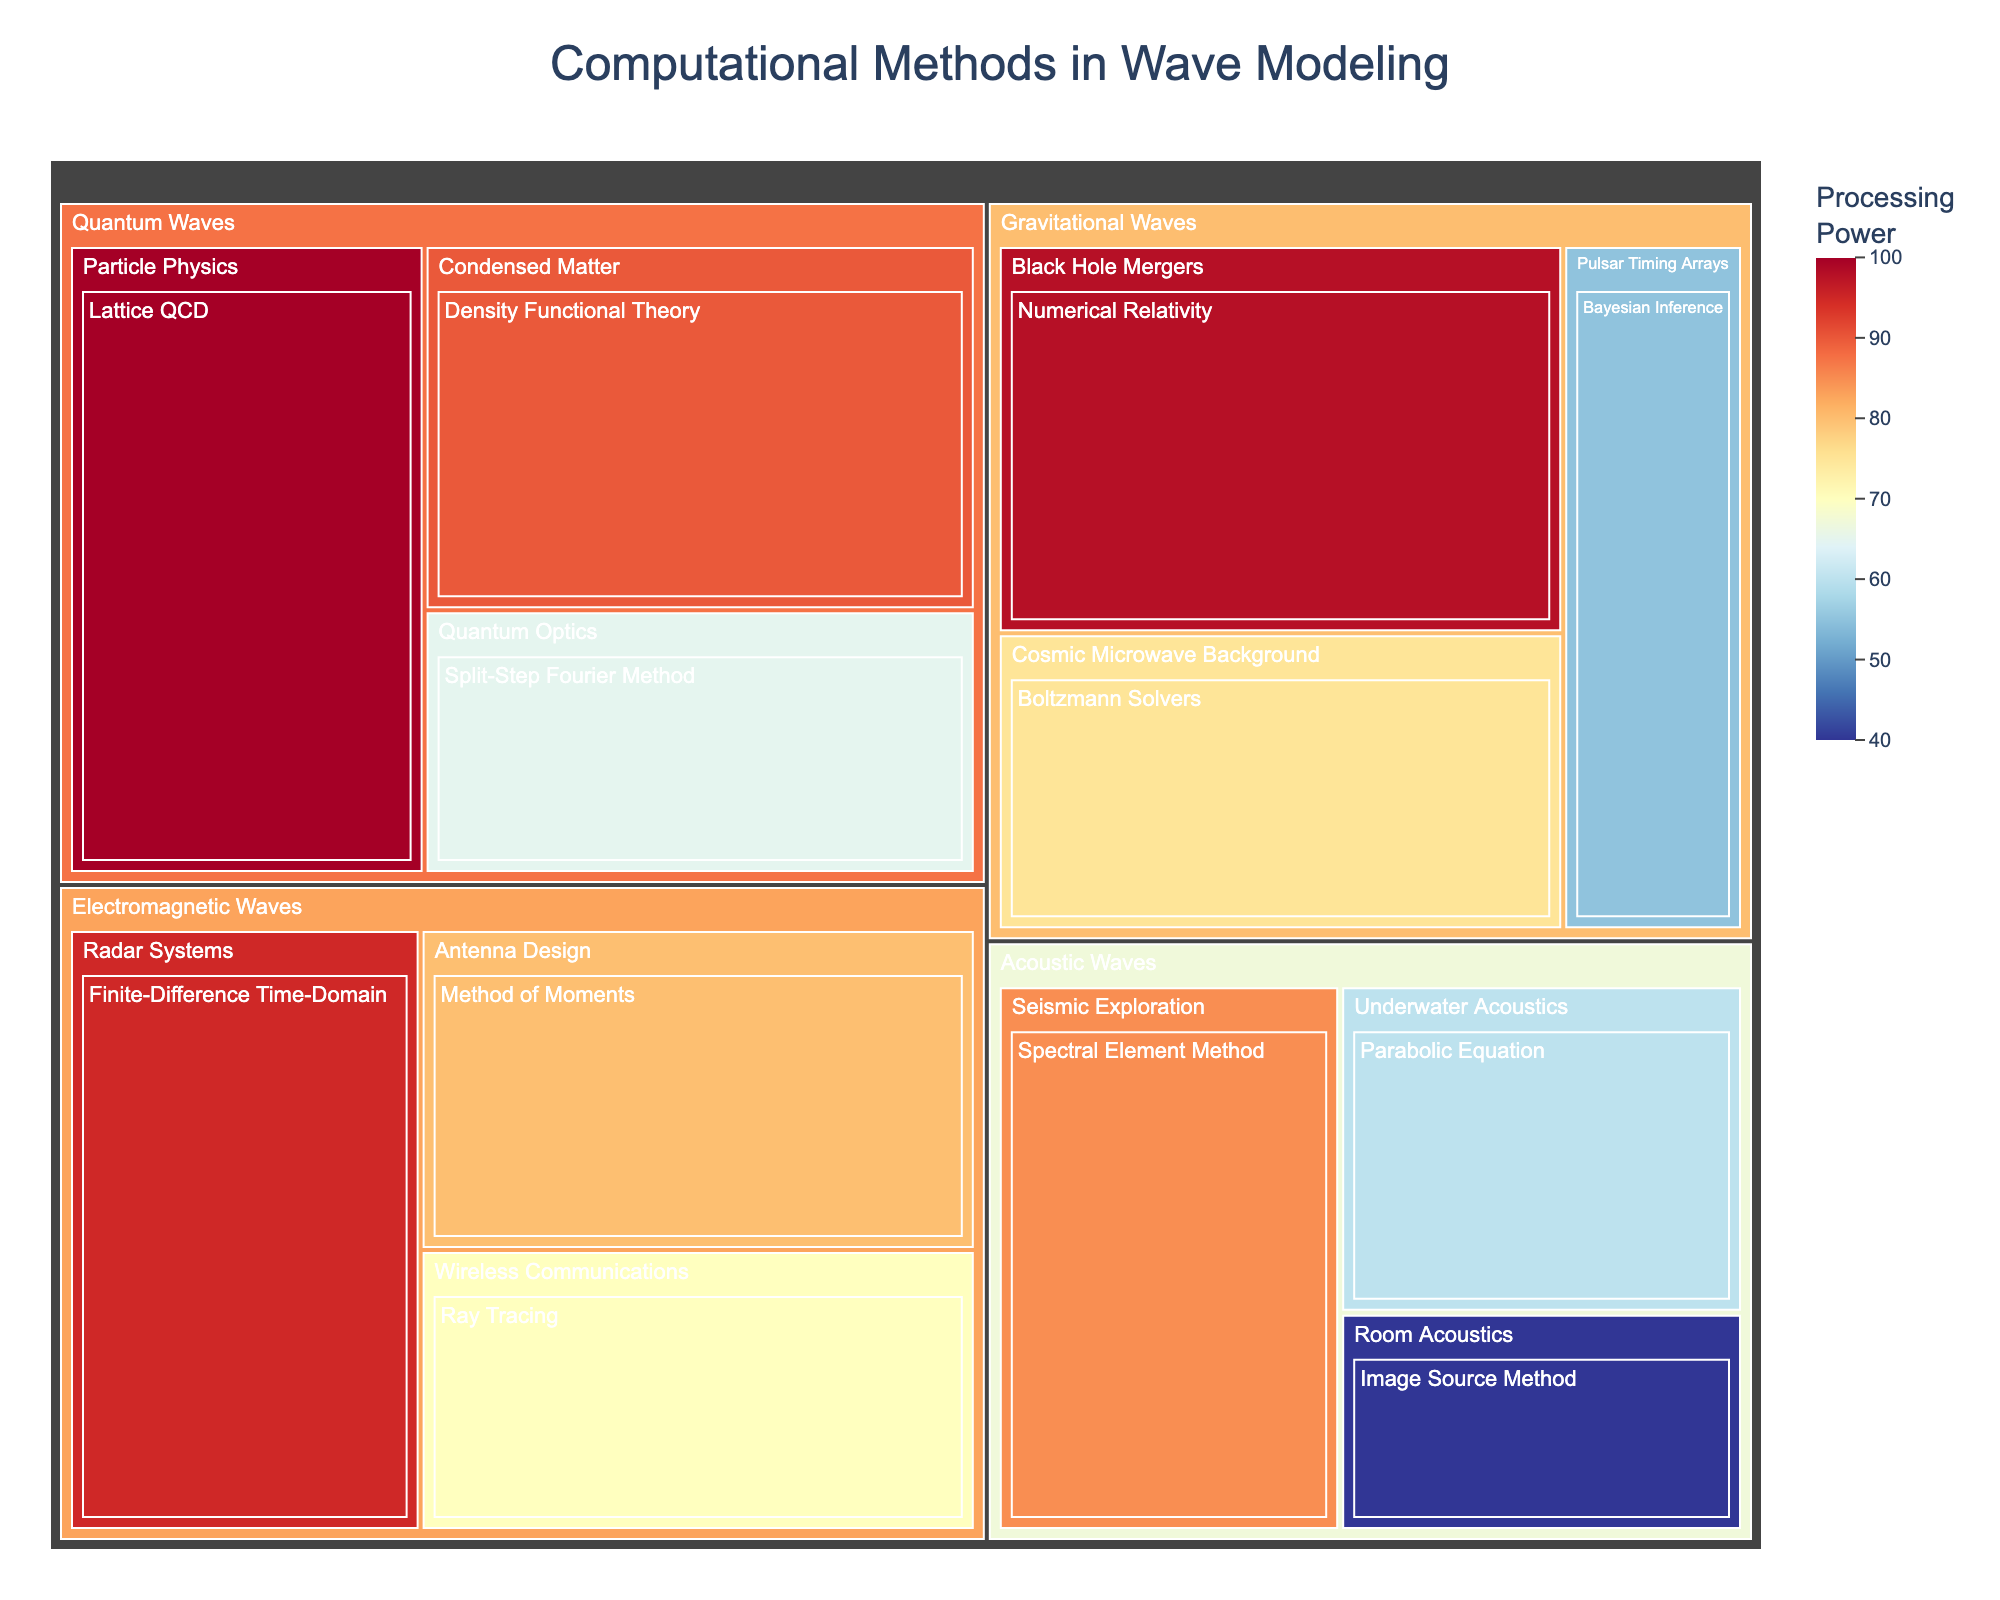1. What is the title of the treemap? The title of the treemap is displayed at the top, indicating the topic of the visualization.
Answer: Computational Methods in Wave Modeling 2. Which computational method in Electromagnetic Waves category requires the highest processing power? The highest processing power requirement in the Electromagnetic Waves category can be identified by looking at the corresponding subcategories. The method with the highest value under Antenna Design, Radar Systems, or Wireless Communications is the one needed.
Answer: Finite-Difference Time-Domain 3. Compare the processing power requirements between the Spectral Element Method and the Bayesian Inference method. The processing power for each method can be found by checking the values in the relevant subcategories. Spectral Element Method is under Seismic Exploration and Bayesian Inference is under Pulsar Timing Arrays. The comparison reveals the relative power requirements.
Answer: Spectral Element Method > Bayesian Inference 4. How many methods are listed under the category of Gravitational Waves? Under the Gravitational Waves category, the number of methods can be counted by looking at the different subcategories and their corresponding methods.
Answer: 3 5. What is the range of processing power for the methods listed under Acoustic Waves category? Identify the minimum and maximum processing power values within the Acoustic Waves category by examining the values associated with all relevant subcategories: Underwater Acoustics, Room Acoustics, and Seismic Exploration.
Answer: 40 to 85 6. If you combine the processing power of all methods in Quantum Waves, what is the total? Sum the processing power values for Density Functional Theory, Lattice QCD, and Split-Step Fourier Method. Adding up 100 + 90 + 65 will yield the total.
Answer: 255 7. Which method has a processing power closest to the median of all listed methods? To find this, list all processing power values, arrange them in order, and determine the middle value (for odd number of entries) or the average of the two middle values (for even number). Identify the method closest to this median value.
Answer: Split-Step Fourier Method 8. What subcategory of wave modeling has the lowest processing power requirement and what is the method? Identify the subcategory with the smallest processing power value by checking all subcategories and their corresponding methods. The method within this subcategory is also required.
Answer: Room Acoustics; Image Source Method 